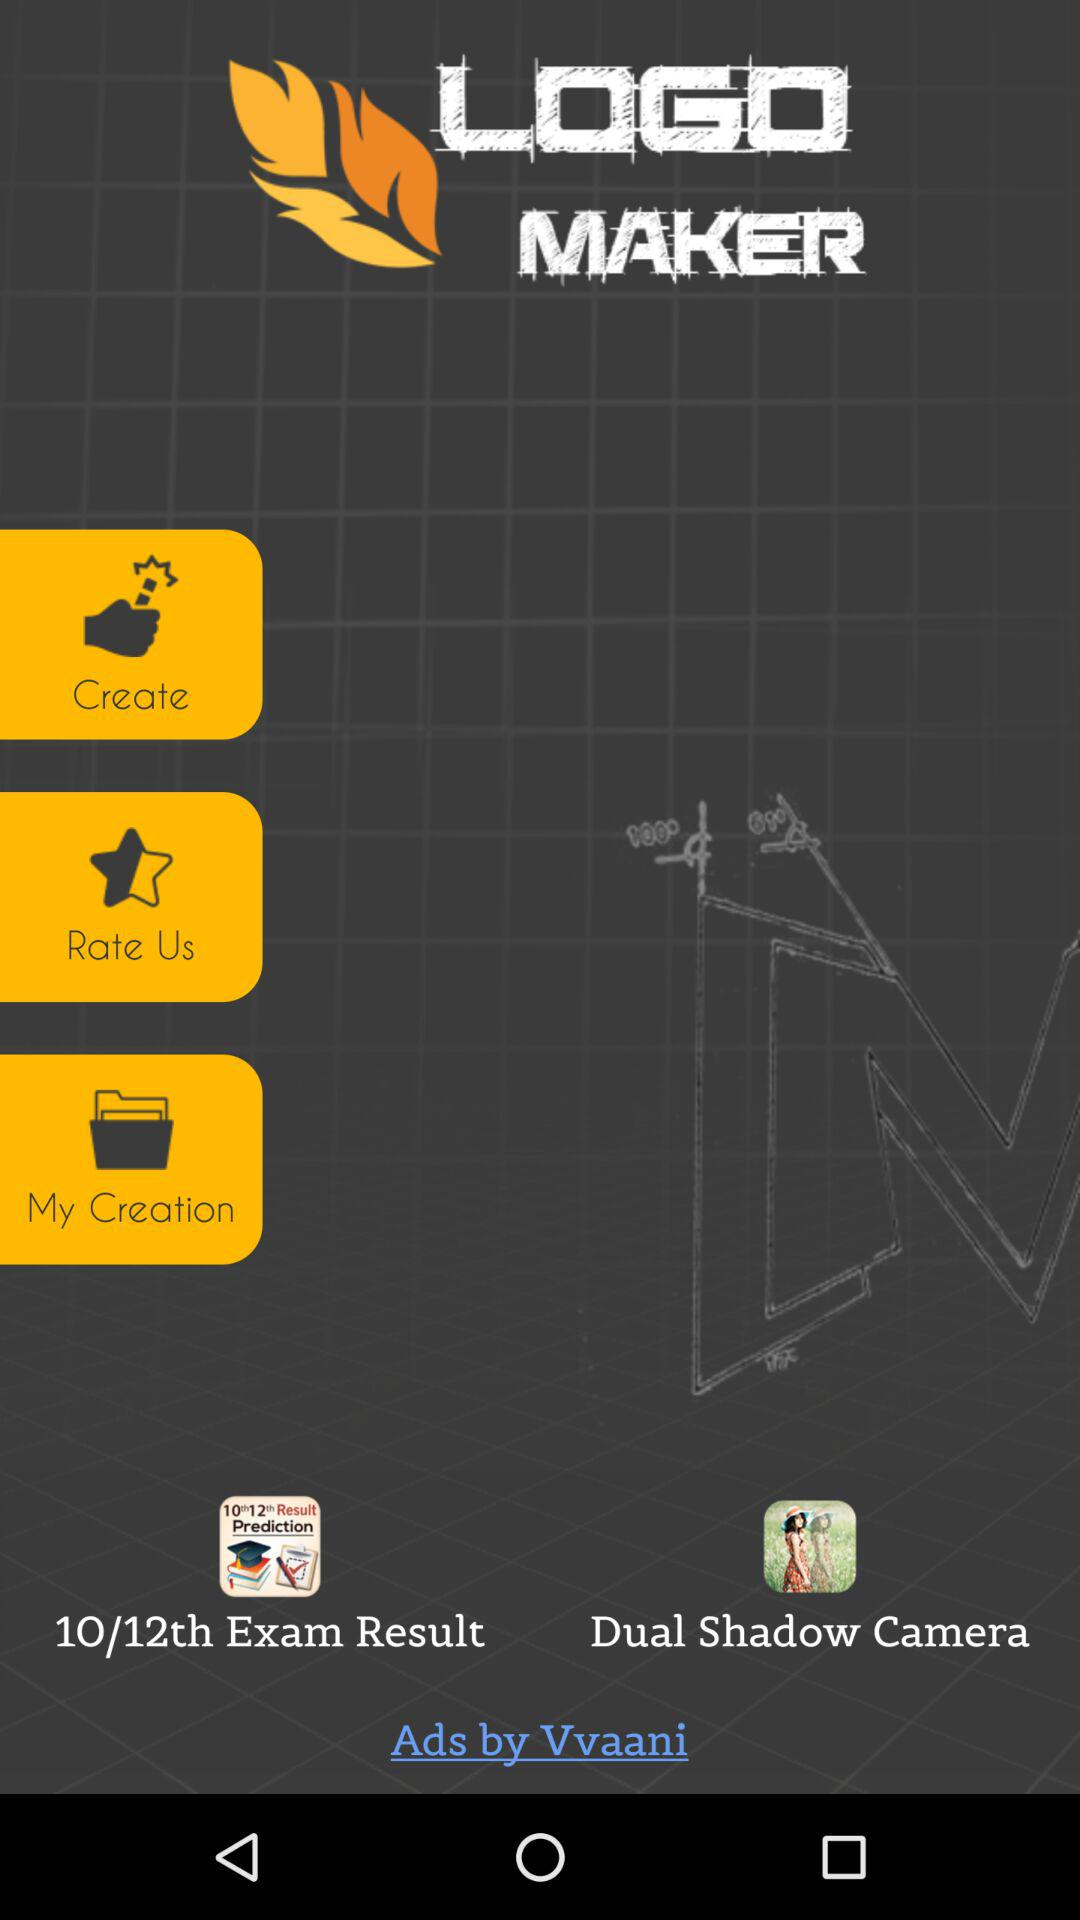What is the application name? The application name is "LOGO MAKER". 